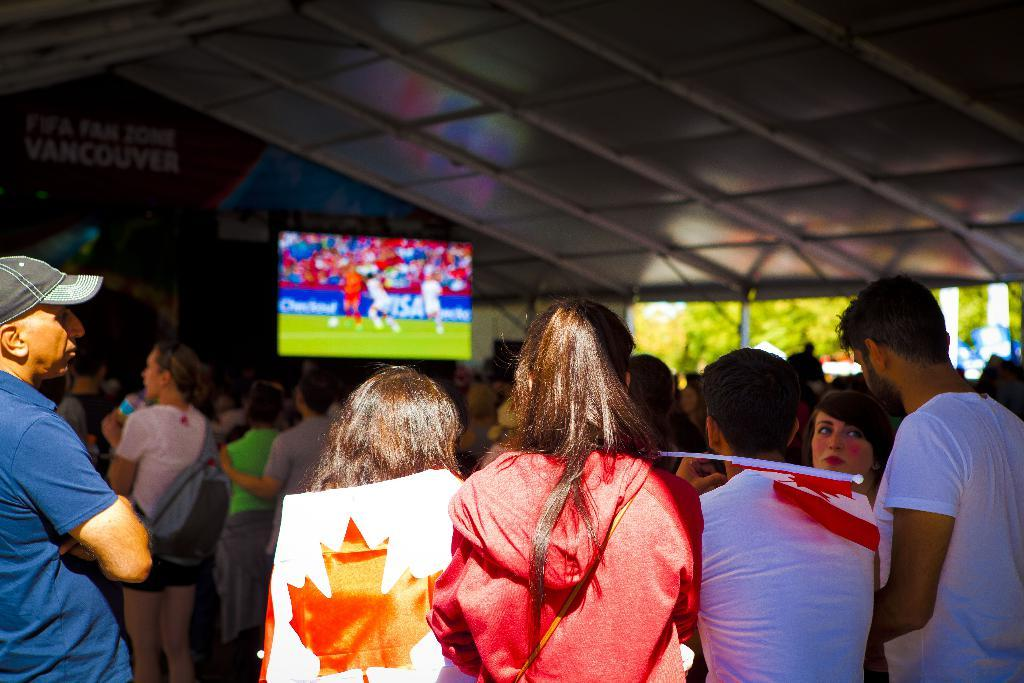Who or what can be seen in the image? There are people in the image. What object is present that represents a country or organization? There is a flag in the image. What electronic device is visible in the image? There is a television in the image. What type of structure can be seen in the image? There is a shed in the image. What type of natural elements are present in the image? There are trees in the image. What type of man-made structures are present in the image? There are poles in the image. How would you describe the background of the image? The background of the image is blurred. What letter is being used as a stop sign in the image? There is no letter being used as a stop sign in the image. What type of attraction can be seen in the background of the image? There is no attraction visible in the image; the background is blurred. 